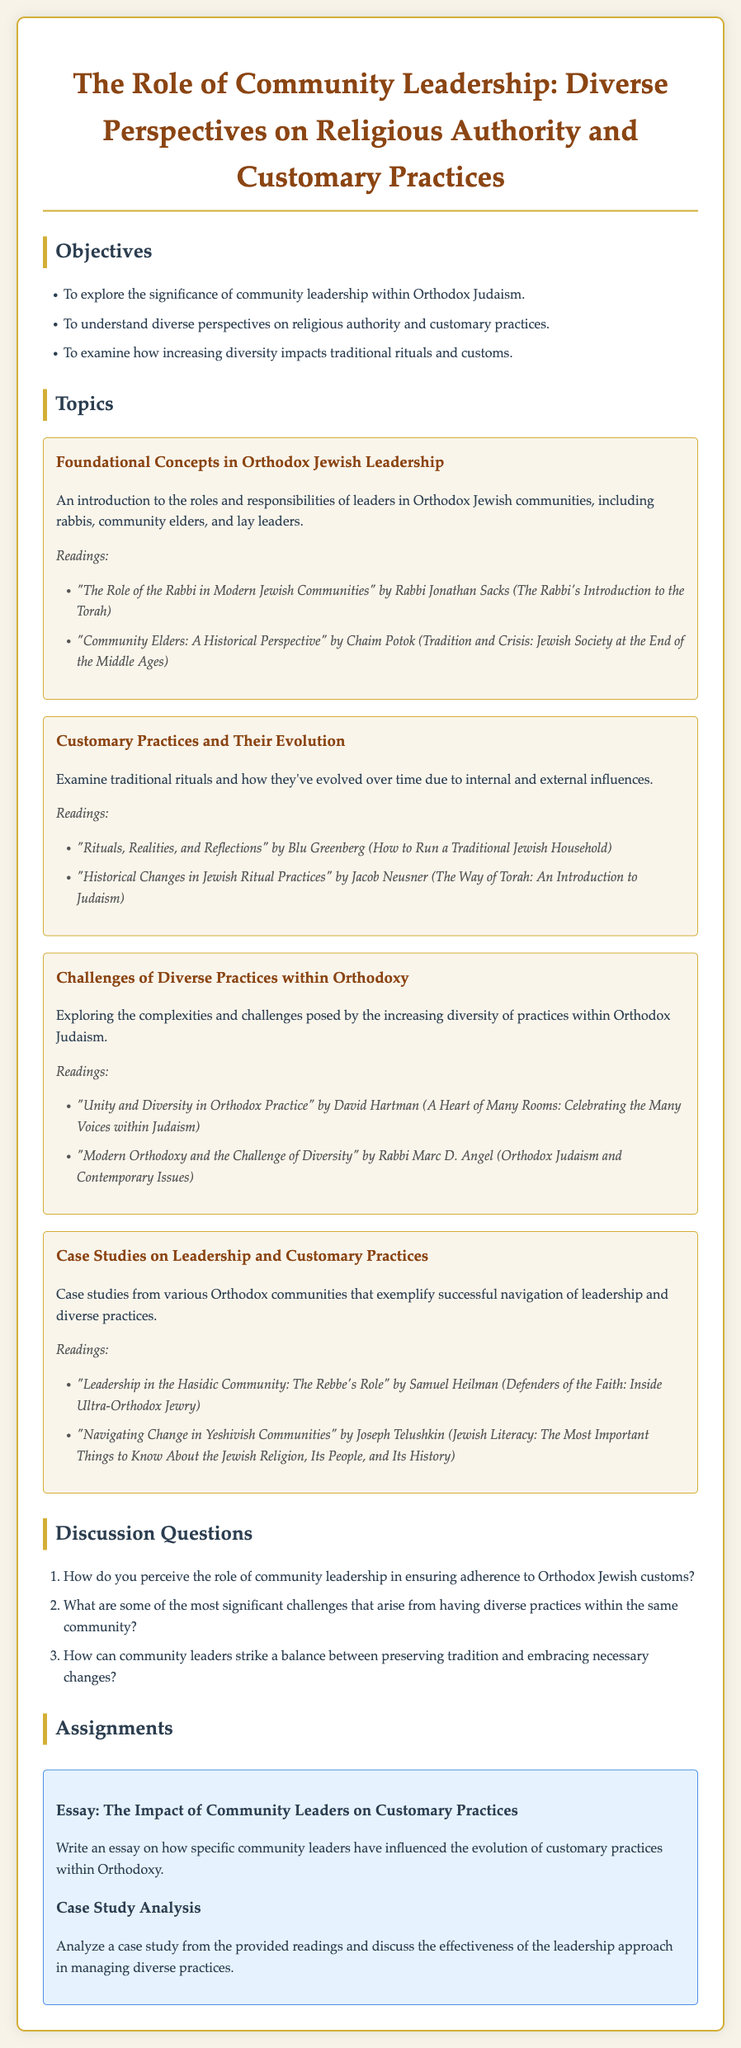What is the title of the syllabus? The title is stated in the document as "The Role of Community Leadership: Diverse Perspectives on Religious Authority and Customary Practices."
Answer: The Role of Community Leadership: Diverse Perspectives on Religious Authority and Customary Practices Who is the author of "The Role of the Rabbi in Modern Jewish Communities"? The author is stated in the document as Rabbi Jonathan Sacks.
Answer: Rabbi Jonathan Sacks What is one of the topics covered in the syllabus? The syllabus outlines several topics, one being "Customary Practices and Their Evolution."
Answer: Customary Practices and Their Evolution How many objectives are listed in the syllabus? The document specifies a total of three objectives under the "Objectives" section.
Answer: 3 Which book discusses "Unity and Diversity in Orthodox Practice"? The document indicates that this topic is covered by David Hartman.
Answer: David Hartman What is the nature of the assignments given in the syllabus? The syllabus provides specific types of assignments, including an essay and a case study analysis.
Answer: Essay and Case Study Analysis What does the first reading under "Foundational Concepts in Orthodox Jewish Leadership" focus on? The first reading discusses the role of rabbis in modern Jewish communities.
Answer: The role of the Rabbi in Modern Jewish Communities How does the syllabus describe the section about challenges of diverse practices? It states that this section explores the complexities and challenges posed by the increasing diversity of practices within Orthodox Judaism.
Answer: Complexities and challenges posed by diversity in practices What type of questions are listed under the "Discussion Questions" section? These questions are designed to provoke discussion and encourage deeper thought about the topics covered in the syllabus.
Answer: Discussion questions 